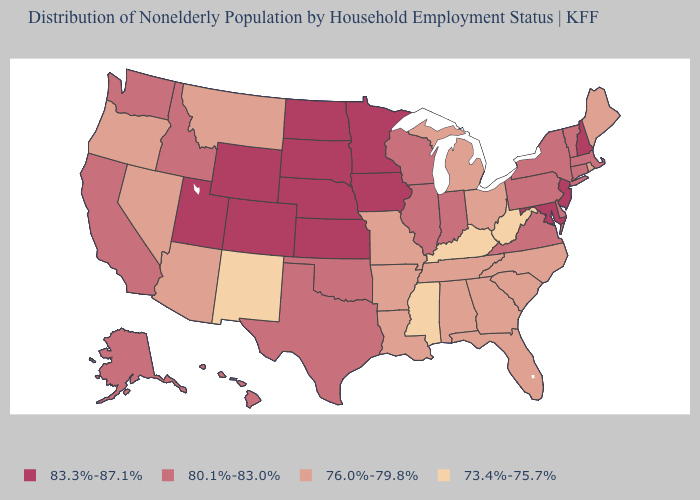Does the map have missing data?
Short answer required. No. Does Utah have a lower value than Montana?
Quick response, please. No. What is the value of Rhode Island?
Short answer required. 76.0%-79.8%. How many symbols are there in the legend?
Answer briefly. 4. What is the lowest value in the USA?
Concise answer only. 73.4%-75.7%. Which states have the lowest value in the USA?
Write a very short answer. Kentucky, Mississippi, New Mexico, West Virginia. What is the lowest value in the USA?
Give a very brief answer. 73.4%-75.7%. Does the first symbol in the legend represent the smallest category?
Keep it brief. No. What is the value of Mississippi?
Give a very brief answer. 73.4%-75.7%. What is the value of Kansas?
Keep it brief. 83.3%-87.1%. Name the states that have a value in the range 83.3%-87.1%?
Be succinct. Colorado, Iowa, Kansas, Maryland, Minnesota, Nebraska, New Hampshire, New Jersey, North Dakota, South Dakota, Utah, Wyoming. Name the states that have a value in the range 83.3%-87.1%?
Give a very brief answer. Colorado, Iowa, Kansas, Maryland, Minnesota, Nebraska, New Hampshire, New Jersey, North Dakota, South Dakota, Utah, Wyoming. What is the lowest value in states that border South Carolina?
Short answer required. 76.0%-79.8%. Does New York have the same value as Tennessee?
Short answer required. No. 